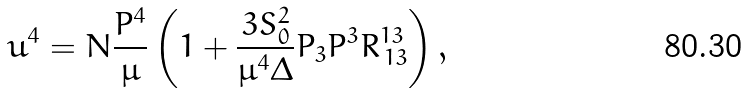Convert formula to latex. <formula><loc_0><loc_0><loc_500><loc_500>u ^ { 4 } = N \frac { P ^ { 4 } } { \mu } \left ( 1 + \frac { 3 S _ { 0 } ^ { 2 } } { \mu ^ { 4 } \Delta } P _ { 3 } P ^ { 3 } R ^ { 1 3 } _ { \, 1 3 } \right ) ,</formula> 